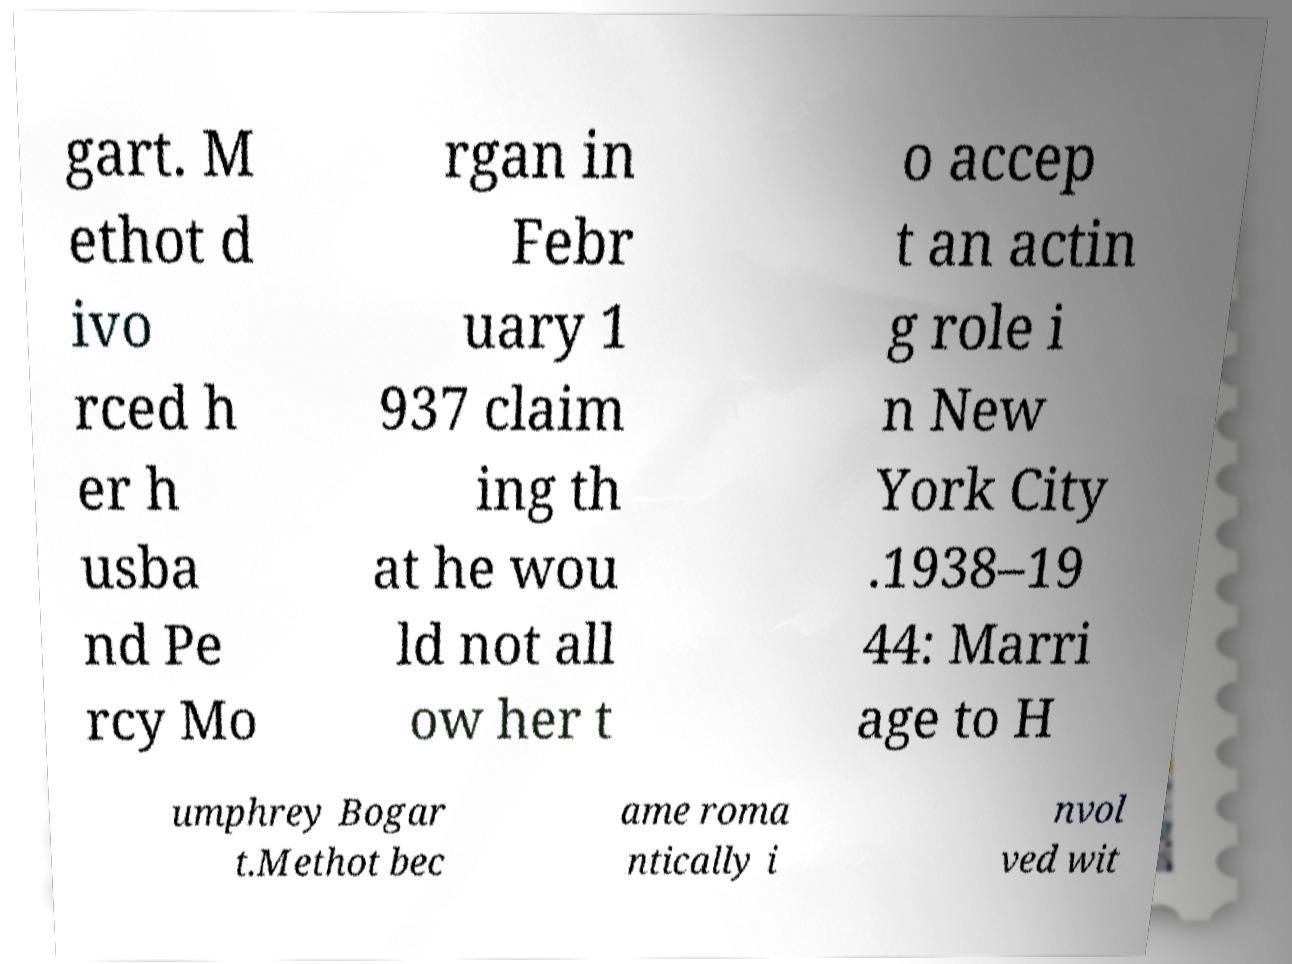Could you assist in decoding the text presented in this image and type it out clearly? gart. M ethot d ivo rced h er h usba nd Pe rcy Mo rgan in Febr uary 1 937 claim ing th at he wou ld not all ow her t o accep t an actin g role i n New York City .1938–19 44: Marri age to H umphrey Bogar t.Methot bec ame roma ntically i nvol ved wit 